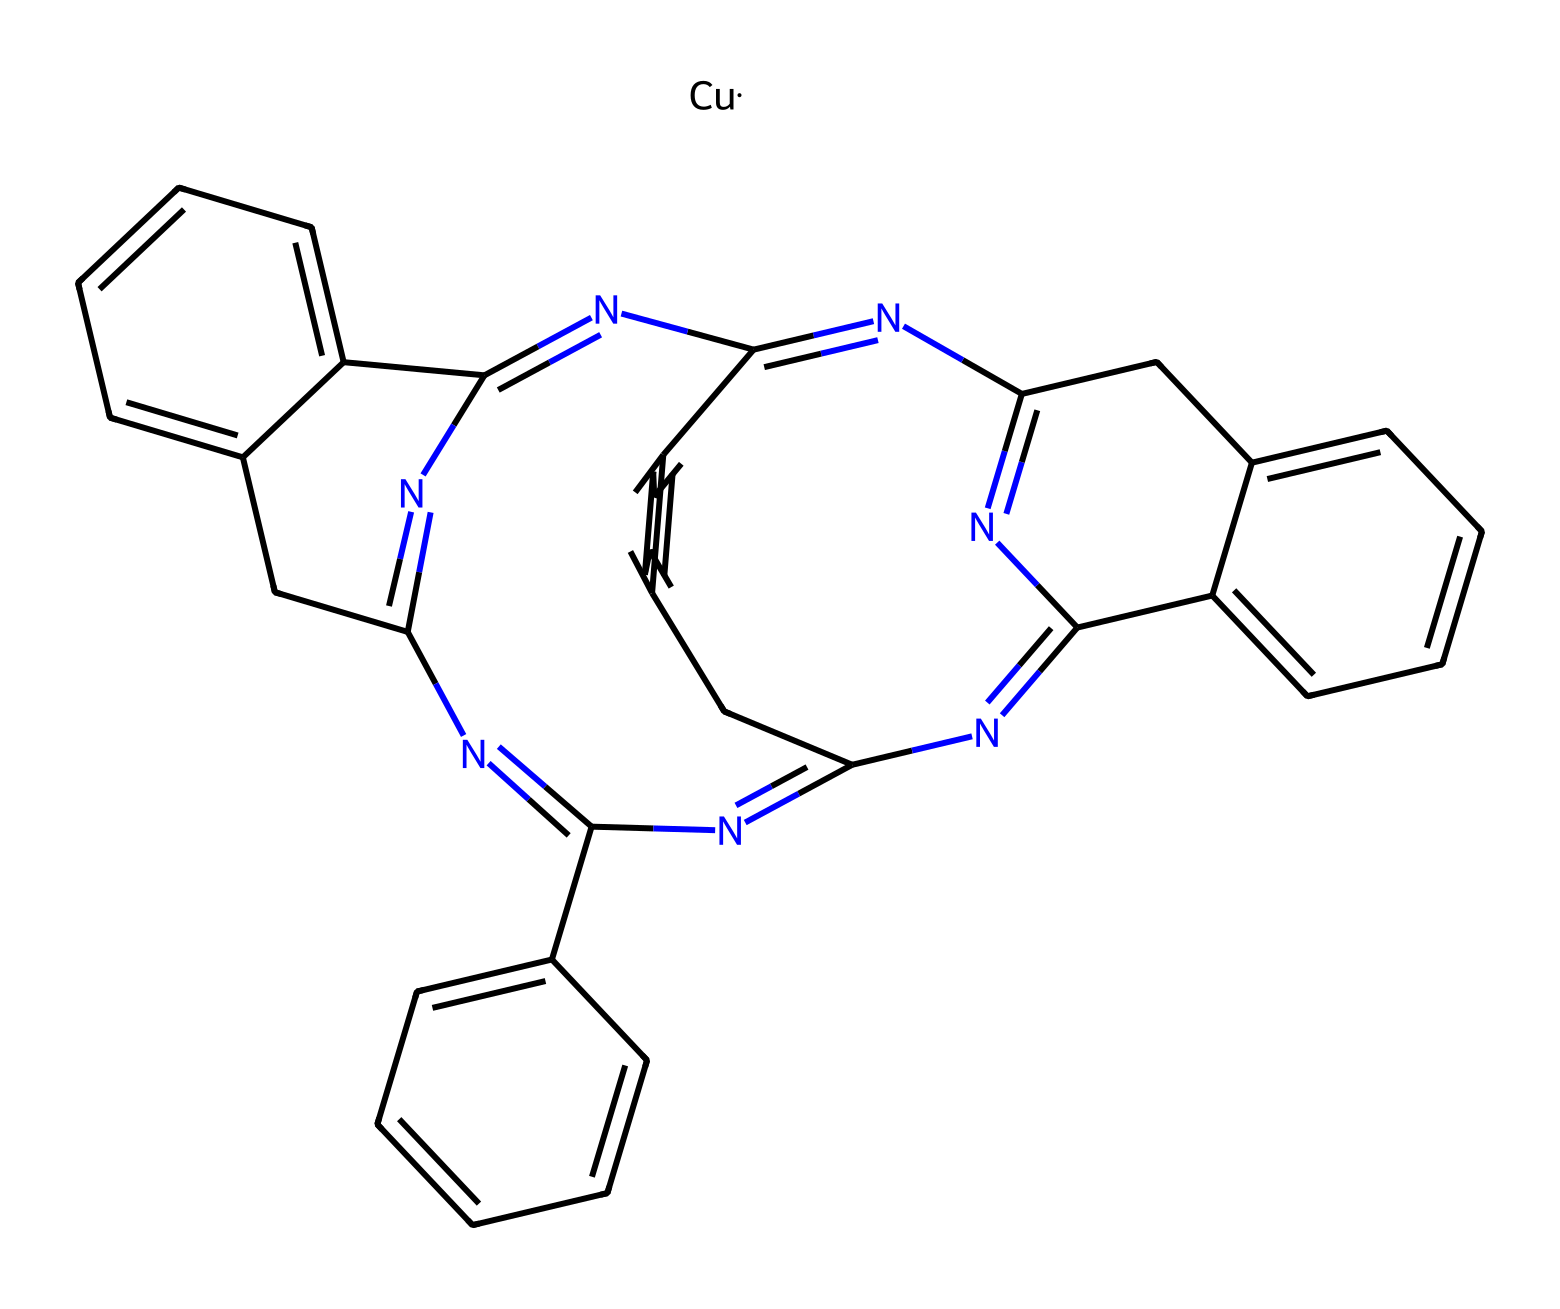What is the coordination number of copper in this compound? The coordination number refers to the number of ligand atoms that are bonded to the central metal atom, in this case, copper. In the structure of copper phthalocyanine, the copper is surrounded by four nitrogen atoms from the phthalocyanine ligands, indicating a coordination number of 4.
Answer: 4 How many nitrogen atoms are present in copper phthalocyanine? To find the number of nitrogen atoms, we can analyze the SMILES representation provided. Counting each nitrogen symbol (N) present throughout the structure shows a total of 8 nitrogen atoms.
Answer: 8 What is the color of copper phthalocyanine? Copper phthalocyanine is commonly known for its distinctive blue color, which is derived from its chemical structure and the arrangement of additional cyclic components.
Answer: blue What type of chemical is copper phthalocyanine? Copper phthalocyanine is classified as a coordination compound, which consists of a central metal atom (copper) bonded to surrounding ligands (the phthalocyanine). This is typical of coordination compounds where metal ions interact with molecules or anions.
Answer: coordination compound Which element serves as the central metal in this compound? The central metal atom in copper phthalocyanine is copper, as indicated explicitly in the SMILES string following the metal designation. It plays a crucial role in the coordination with the surrounding ligands, giving rise to its specific properties.
Answer: copper What structural feature defines the aromaticity of the ligands in copper phthalocyanine? The aromaticity in copper phthalocyanine is primarily defined by the presence of conjugated pi-electron systems formed by the alternating double and single bonds in the benzene ring-like structures (the phthalocyanine part) that surround the copper. These structures meet the criteria for aromatic stability.
Answer: conjugated pi-electron systems 